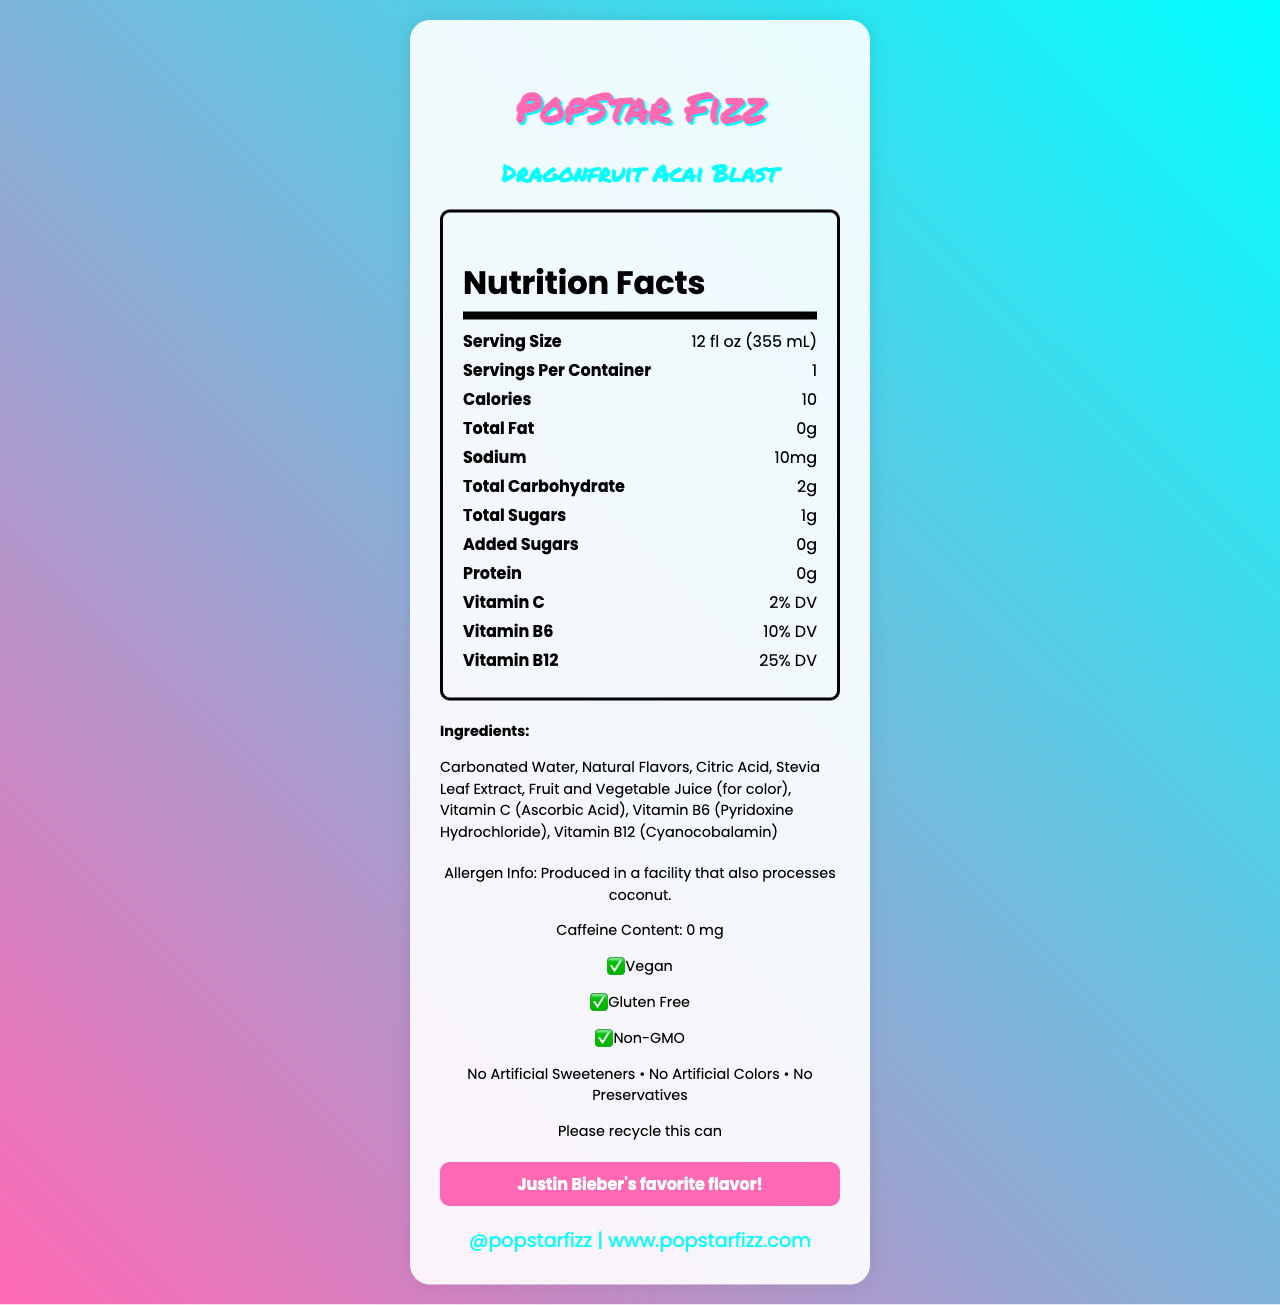what is the serving size? The serving size is listed as "12 fl oz (355 mL)" in the Nutrition Facts section.
Answer: 12 fl oz (355 mL) how many servings are in one container? The document states that there is 1 serving per container.
Answer: 1 how many calories are in a serving of PopStar Fizz? The Nutrition Facts section indicates that there are 10 calories per serving.
Answer: 10 what is the amount of total fat in PopStar Fizz? The total fat is listed as 0g in the Nutrition Facts section.
Answer: 0g how much sodium is in one serving? The sodium content is listed as 10mg in the Nutrition Facts section.
Answer: 10mg how many total carbohydrates does PopStar Fizz contain? The Nutrition Facts section indicates 2g of total carbohydrates per serving.
Answer: 2g what is the total amount of sugars in PopStar Fizz? The total sugars are listed as 1g in the Nutrition Facts section.
Answer: 1g how much added sugar is in PopStar Fizz? The provided data states there are 0g of added sugars.
Answer: 0g what protein content does PopStar Fizz have? The Nutrition Facts section lists that PopStar Fizz has 0g of protein.
Answer: 0g which vitamins are included in PopStar Fizz, and what is their percentage daily value? The document lists Vitamin C at 2% DV, Vitamin B6 at 10% DV, and Vitamin B12 at 25% DV.
Answer: Vitamin C: 2% DV, Vitamin B6: 10% DV, Vitamin B12: 25% DV what are the main ingredients in PopStar Fizz? The document lists the ingredients in the Ingredients section.
Answer: Carbonated Water, Natural Flavors, Citric Acid, Stevia Leaf Extract, Fruit and Vegetable Juice (for color), Vitamin C (Ascorbic Acid), Vitamin B6 (Pyridoxine Hydrochloride), Vitamin B12 (Cyanocobalamin) PopStar Fizz contains which of the following allergens? A. Peanuts B. Milk C. Coconut The allergen information states it is produced in a facility that also processes coconut.
Answer: C. Coconut how much caffeine does PopStar Fizz contain? The document lists the caffeine content as 0 mg.
Answer: 0 mg is PopStar Fizz suitable for vegans? The document indicates that PopStar Fizz is vegan.
Answer: Yes does PopStar Fizz contain any artificial sweeteners or colors? The additional claims section states "No Artificial Sweeteners" and "No Artificial Colors."
Answer: No if someone wants to recycle the PopStar Fizz can, what should they do? The document states, "Please recycle this can".
Answer: Please recycle this can which of the following is NOT true about PopStar Fizz? A. It is non-GMO B. It contains artificial preservatives C. It is vegan The additional claims section states "No Preservatives," indicating that B is false.
Answer: B. It contains artificial preservatives summary the main information presented in the document. The document details the nutritional content, ingredient list, allergen info, and additional claims of the PopStar Fizz drink, emphasizing its low-calorie content and health-friendly properties.
Answer: PopStar Fizz is a Dragonfruit Acai Blast flavored sparkling water that is low in calories (10 per serving) and free from total fat, added sugars, caffeine, and artificial ingredients. It includes vitamins C, B6, and B12 and is suitable for vegans, gluten-free, and non-GMO. The drink is also made in a facility that processes coconut. how many cans of PopStar Fizz does Justin Bieber drink in a week? The document does not provide any information regarding Justin Bieber's consumption habits.
Answer: Not enough information which social media handle can people use to follow PopStar Fizz online? The document lists the social media handle as @popstarfizz.
Answer: @popstarfizz 